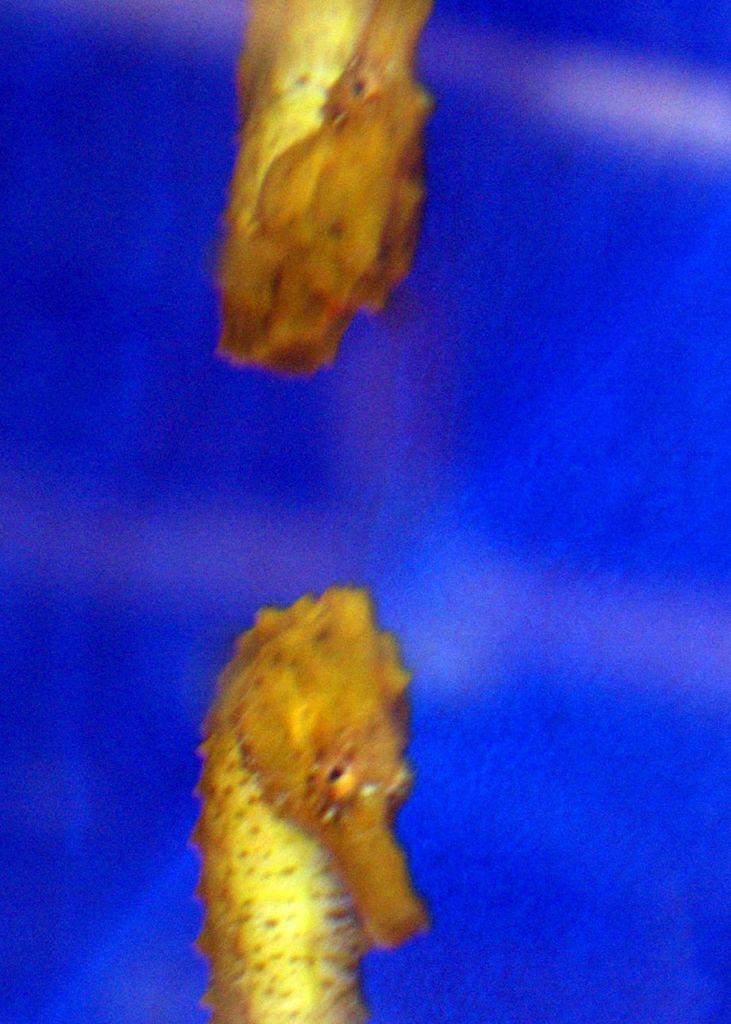Could you give a brief overview of what you see in this image? In this image there are two seahorse fishes, the background of the image is blue in color. 